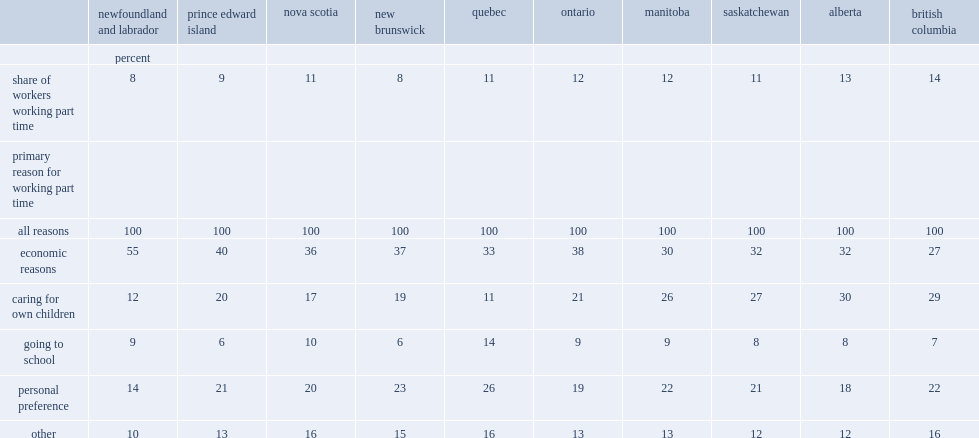What was the percentage of core-aged workers in british columbia had a part-time schedule? 14.0. What was the percentage of core-aged workers in new brunswick had a part-time schedule? 8.0. What was the percentage of core-aged workers in newfoundland and labrador had a part-time schedule? 8.0. What was the percentage of core-aged part-time workers in newfoundland and labrador cited economic reasons as the primary driver for their work schedule? 55.0. What was the percentage of core-aged workers in quebec cited childcare as the primary driver for their work schedule? 11.0. What was the percentage of core-aged workers in quebec cited personal preference as the primary driver for their work schedule? 26.0. What was the percentage of core-aged workers in quebec cited attending school as the primary driver for their work schedule? 14.0. 